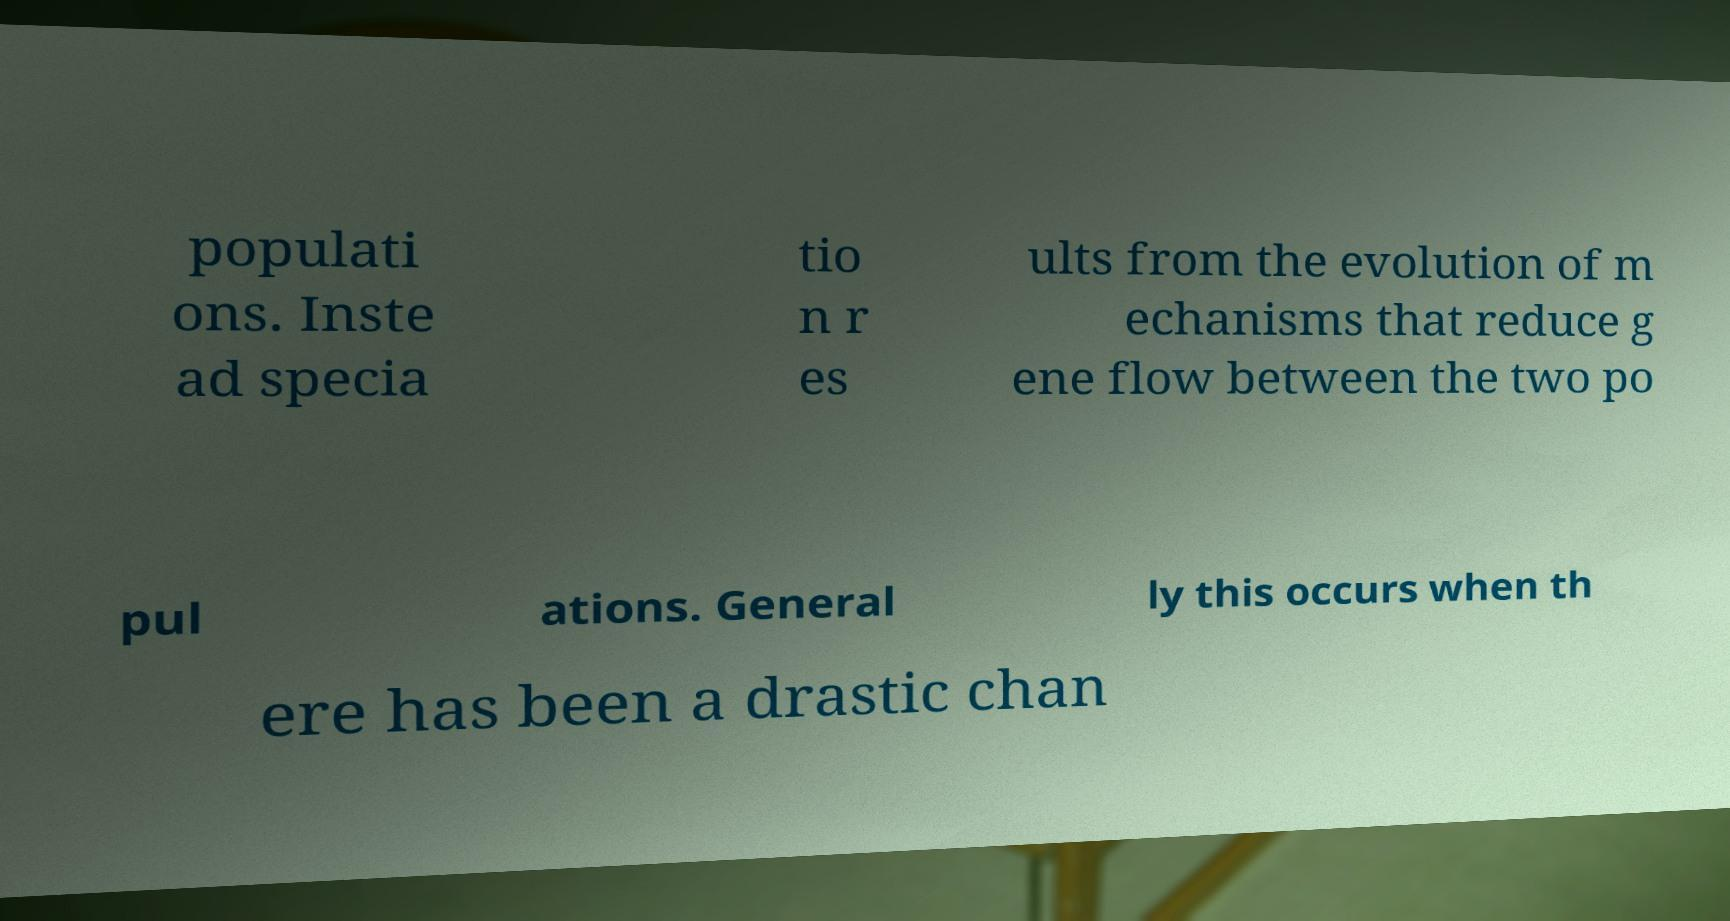There's text embedded in this image that I need extracted. Can you transcribe it verbatim? populati ons. Inste ad specia tio n r es ults from the evolution of m echanisms that reduce g ene flow between the two po pul ations. General ly this occurs when th ere has been a drastic chan 